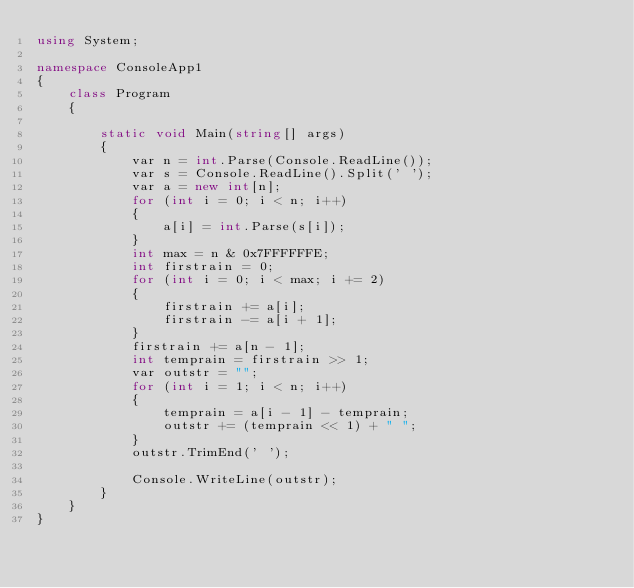Convert code to text. <code><loc_0><loc_0><loc_500><loc_500><_C#_>using System;

namespace ConsoleApp1
{
    class Program
    {

        static void Main(string[] args)
        {
            var n = int.Parse(Console.ReadLine());
            var s = Console.ReadLine().Split(' ');
            var a = new int[n];
            for (int i = 0; i < n; i++)
            {
                a[i] = int.Parse(s[i]);
            }
            int max = n & 0x7FFFFFFE;
            int firstrain = 0;
            for (int i = 0; i < max; i += 2)
            {
                firstrain += a[i];
                firstrain -= a[i + 1];
            }
            firstrain += a[n - 1];
            int temprain = firstrain >> 1;
            var outstr = "";
            for (int i = 1; i < n; i++)
            {
                temprain = a[i - 1] - temprain;
                outstr += (temprain << 1) + " ";
            }
            outstr.TrimEnd(' ');

            Console.WriteLine(outstr);
        }
    }
}
</code> 